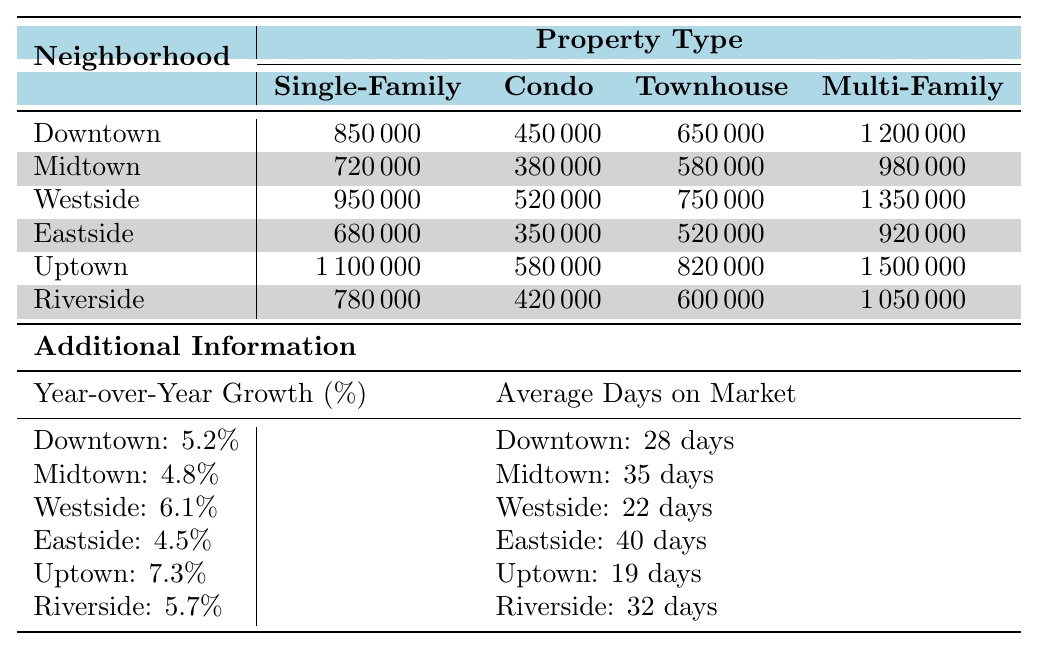What is the property value of a Single-Family Home in Uptown? The table lists the value of a Single-Family Home in the Uptown neighborhood as 1,100,000.
Answer: 1,100,000 Which property type is the most expensive in Westside? In the Westside neighborhood, the Multi-Family property type is the most expensive, valued at 1,350,000.
Answer: Multi-Family What is the difference in property value between a Condo in Downtown and a Condo in Eastside? The value of a Condo in Downtown is 450,000 and in Eastside is 350,000. The difference is 450,000 - 350,000 = 100,000.
Answer: 100,000 How many days on average do properties in Riverside take to sell? The average days on the market for properties in Riverside is noted as 32 days in the table.
Answer: 32 days Which neighborhood has the highest Year-over-Year Growth percentage? The Uptown neighborhood has the highest Year-over-Year Growth percentage at 7.3%, as recorded in the additional information section of the table.
Answer: Uptown What are the average prices of Townhouses in Downtown and Midtown combined? The value of Townhouses in Downtown is 650,000 and in Midtown is 580,000. Summing these gives 650,000 + 580,000 = 1,230,000. Since there are 2 neighborhoods, the average price is 1,230,000 / 2 = 615,000.
Answer: 615,000 Is the average Days on Market for Single-Family Homes in Eastside less than in Downtown? The average Days on Market for Eastside is 40 days, while it is 28 days for Downtown. Since 40 is greater than 28, the statement is false.
Answer: No Which property type has the largest price range in Midtown? The property prices for Midtown are 720,000 (Single-Family Home), 380,000 (Condo), 580,000 (Townhouse), and 980,000 (Multi-Family). The range is 980,000 - 380,000 = 600,000.
Answer: 600,000 If you were to invest in the highest valued Multi-Family property, which neighborhood would you choose? The highest valued Multi-Family property is in Uptown at 1,500,000. The table shows this value as the highest.
Answer: Uptown What is the average property value for Condos across all neighborhoods? The Condo values are 450,000 (Downtown), 380,000 (Midtown), 520,000 (Westside), 350,000 (Eastside), 580,000 (Uptown), and 420,000 (Riverside). Summing these gives 2,700,000 and dividing by 6 gives an average of 450,000.
Answer: 450,000 